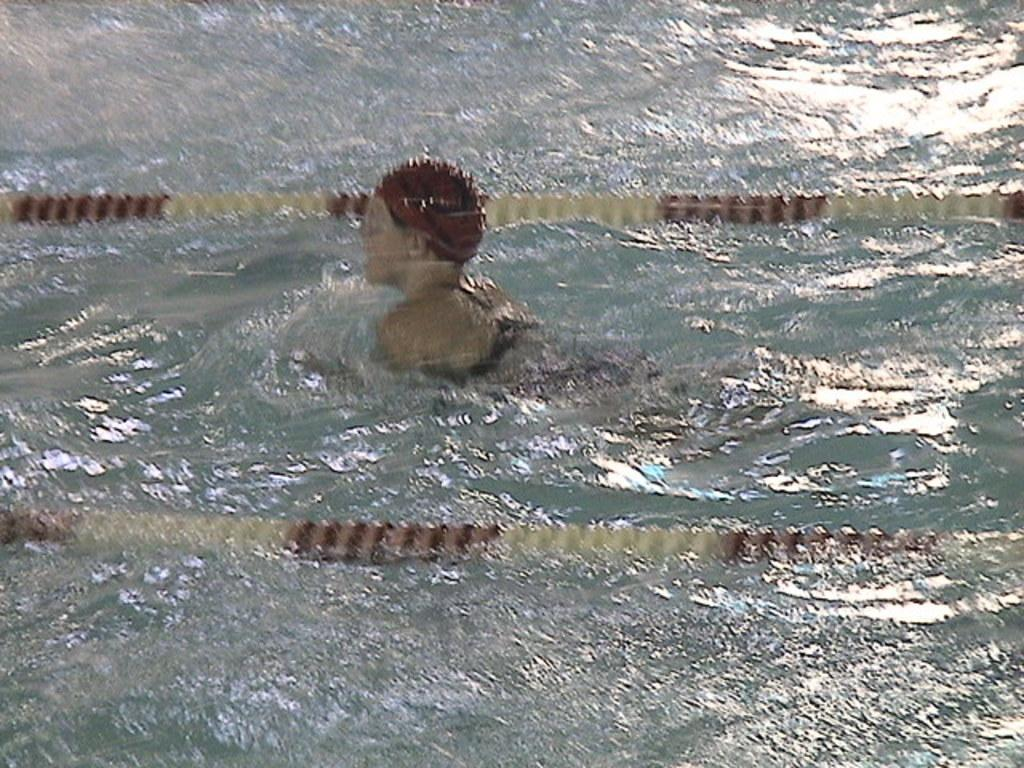Who is the main subject in the image? There is a woman in the image. What is the woman doing in the image? The woman is swimming in the water. Can you describe the environment where the woman is swimming? The water might be in a swimming pool, but it is not explicitly stated. What can be seen near the woman while she is swimming? There are ropes on either side of the woman, with one being white and the other being brown. What type of pickle is the woman holding while swimming in the image? There is no pickle present in the image; the woman is swimming in water with ropes on either side. 